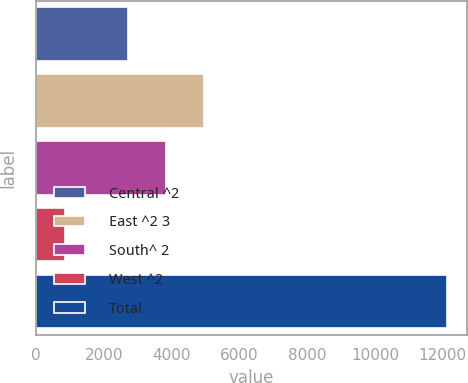Convert chart. <chart><loc_0><loc_0><loc_500><loc_500><bar_chart><fcel>Central ^2<fcel>East ^2 3<fcel>South^ 2<fcel>West ^2<fcel>Total<nl><fcel>2711.2<fcel>4959.88<fcel>3835.54<fcel>875.1<fcel>12118.5<nl></chart> 